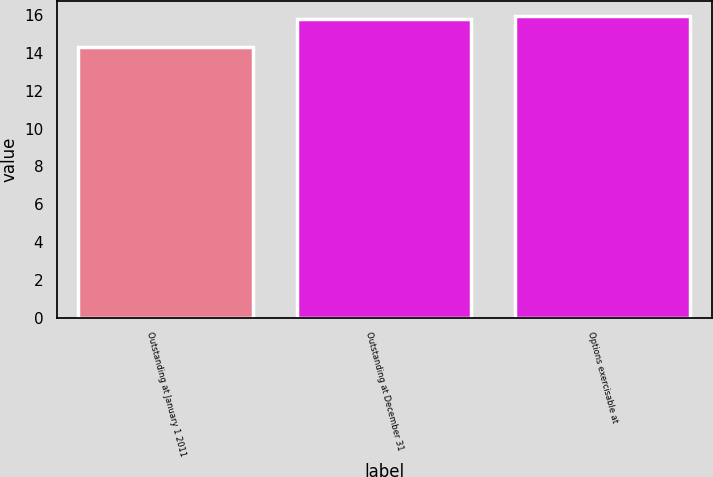Convert chart. <chart><loc_0><loc_0><loc_500><loc_500><bar_chart><fcel>Outstanding at January 1 2011<fcel>Outstanding at December 31<fcel>Options exercisable at<nl><fcel>14.32<fcel>15.82<fcel>15.97<nl></chart> 